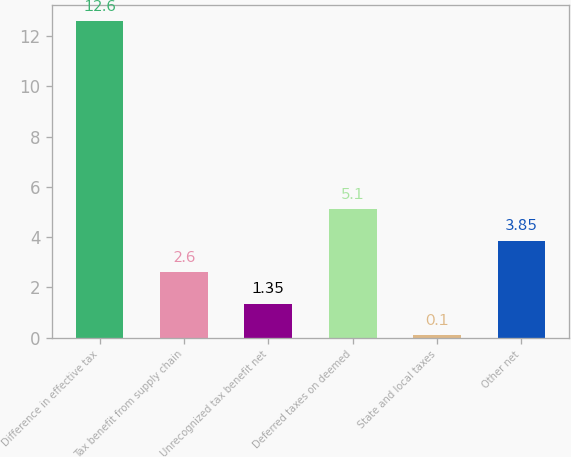Convert chart. <chart><loc_0><loc_0><loc_500><loc_500><bar_chart><fcel>Difference in effective tax<fcel>Tax benefit from supply chain<fcel>Unrecognized tax benefit net<fcel>Deferred taxes on deemed<fcel>State and local taxes<fcel>Other net<nl><fcel>12.6<fcel>2.6<fcel>1.35<fcel>5.1<fcel>0.1<fcel>3.85<nl></chart> 